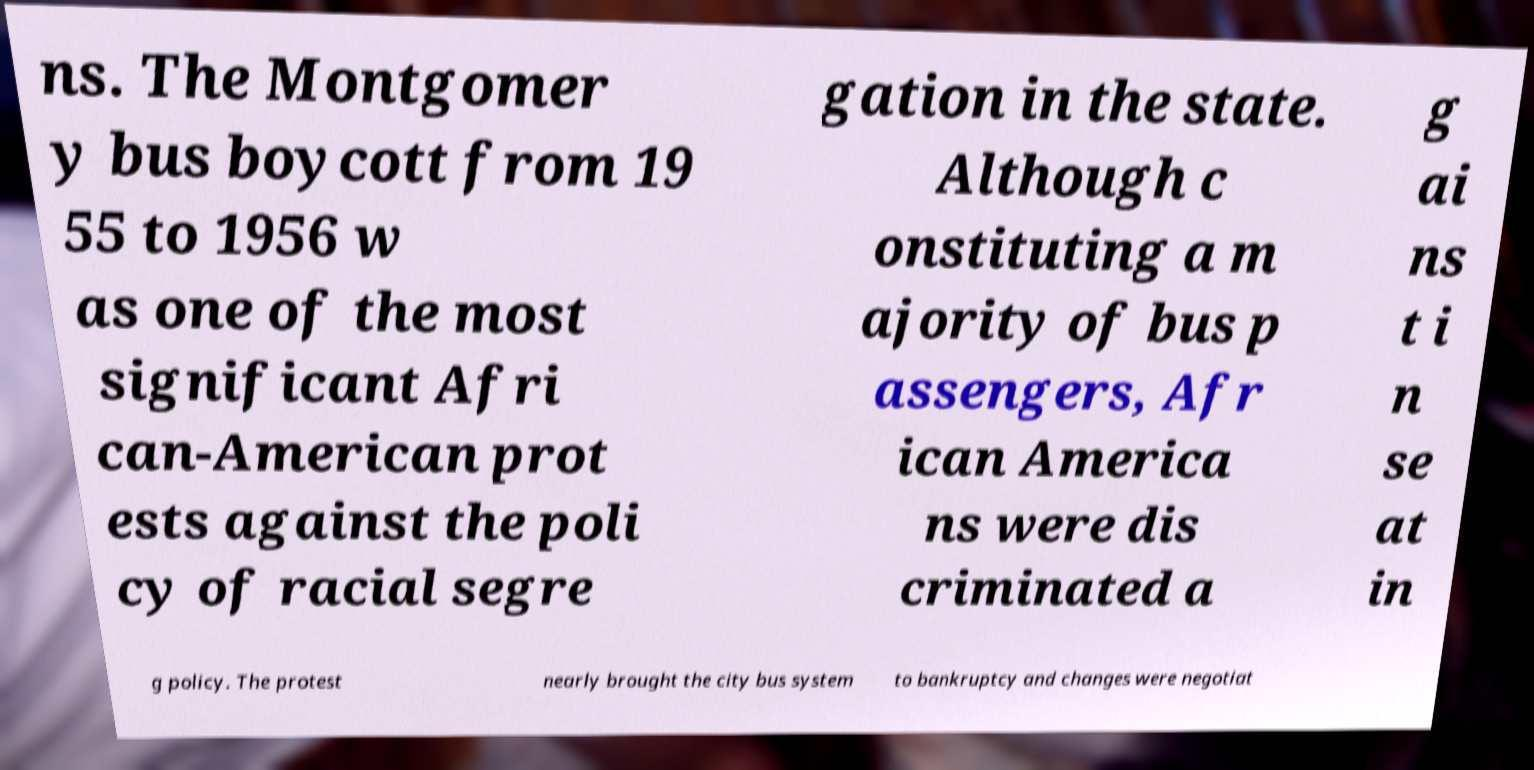For documentation purposes, I need the text within this image transcribed. Could you provide that? ns. The Montgomer y bus boycott from 19 55 to 1956 w as one of the most significant Afri can-American prot ests against the poli cy of racial segre gation in the state. Although c onstituting a m ajority of bus p assengers, Afr ican America ns were dis criminated a g ai ns t i n se at in g policy. The protest nearly brought the city bus system to bankruptcy and changes were negotiat 